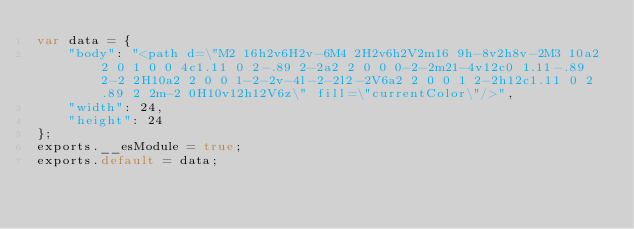Convert code to text. <code><loc_0><loc_0><loc_500><loc_500><_JavaScript_>var data = {
	"body": "<path d=\"M2 16h2v6H2v-6M4 2H2v6h2V2m16 9h-8v2h8v-2M3 10a2 2 0 1 0 0 4c1.11 0 2-.89 2-2a2 2 0 0 0-2-2m21-4v12c0 1.11-.89 2-2 2H10a2 2 0 0 1-2-2v-4l-2-2l2-2V6a2 2 0 0 1 2-2h12c1.11 0 2 .89 2 2m-2 0H10v12h12V6z\" fill=\"currentColor\"/>",
	"width": 24,
	"height": 24
};
exports.__esModule = true;
exports.default = data;
</code> 